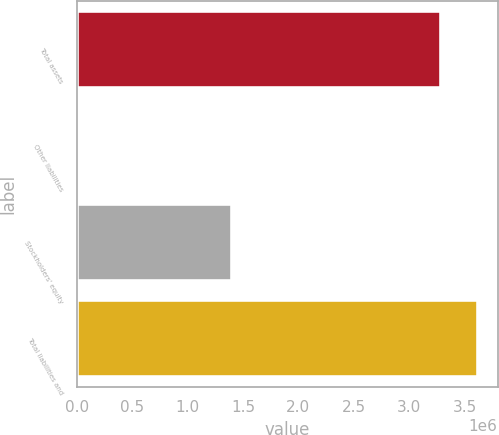Convert chart. <chart><loc_0><loc_0><loc_500><loc_500><bar_chart><fcel>Total assets<fcel>Other liabilities<fcel>Stockholders' equity<fcel>Total liabilities and<nl><fcel>3.28947e+06<fcel>2<fcel>1.40586e+06<fcel>3.61842e+06<nl></chart> 